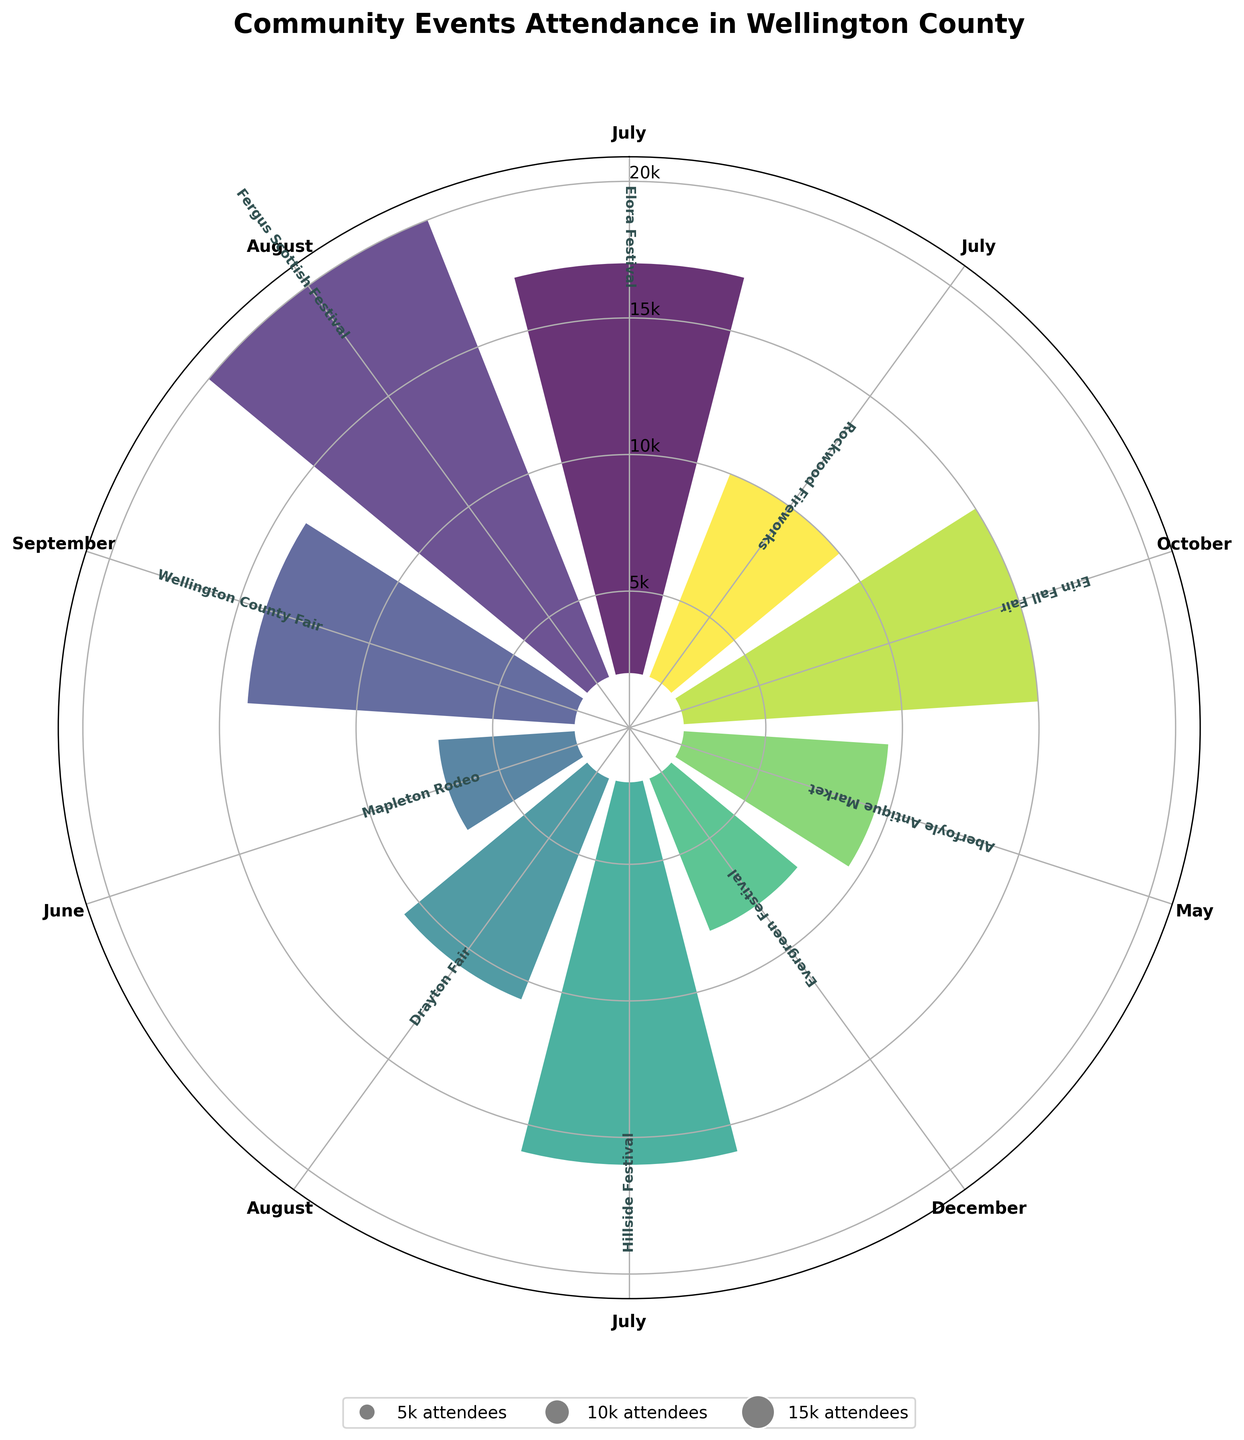Which event has the highest attendance? The event with the highest attendance is represented by the tallest bar on the chart and the widest-point outward from the center.
Answer: Fergus Scottish Festival How many events occur in the month of July? Look for bars labeled with July and count them. There are three events in July labeled on the chart.
Answer: Three Which months have the least and most number of events? Count the number of events in each month by observing the labeled bars.
Answer: December has the least, July and August have the most What is the combined attendance for events in August? Sum the heights of the bars labeled for August (Fergus Scottish Festival 18,000 and Drayton Fair 8,700).
Answer: 26,700 Which event in October, if any, has an attendance greater than 10,000? Identify the event labeled with October and check its attendance. The Erin Fall Fair in October has 13,000 attendees.
Answer: Erin Fall Fair Do any events in May reach at least 10,000 attendees? Check the attendance of the event labeled with May. The Aberfoyle Antique Market in May has 7,500 attendees.
Answer: No What is the average attendance for events held in July? Identify all events in July, sum their attendances (Elora Festival 15,000 + Hillside Festival 14,000 + Rockwood Fireworks 8,000) and divide by the number of events.
Answer: 12,333 How much larger is the attendance for the Elora Festival than the Mapleton Rodeo? Subtract the attendance of Mapleton Rodeo from Elora Festival (15,000 - 5,000).
Answer: 10,000 What is the second most attended event of the year? Identify the event with the second tallest bar. The Elora Festival follows the Fergus Scottish Festival.
Answer: Elora Festival Which months do not have any events listed? Observe the chart and list the months without any labeled bars.
Answer: January, February, March, April, November 